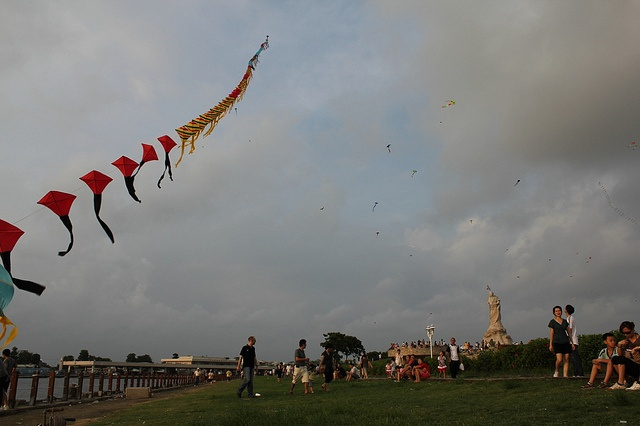Describe the objects in this image and their specific colors. I can see kite in darkgray, gray, and teal tones, kite in darkgray, maroon, and olive tones, people in darkgray, black, maroon, and brown tones, kite in darkgray, maroon, black, and gray tones, and people in darkgray, black, brown, maroon, and gray tones in this image. 